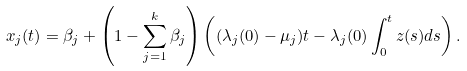<formula> <loc_0><loc_0><loc_500><loc_500>x _ { j } ( t ) & = \beta _ { j } + \left ( 1 - \sum _ { j = 1 } ^ { k } \beta _ { j } \right ) \left ( ( \lambda _ { j } ( 0 ) - \mu _ { j } ) t - \lambda _ { j } ( 0 ) \int _ { 0 } ^ { t } z ( s ) d s \right ) . \\</formula> 